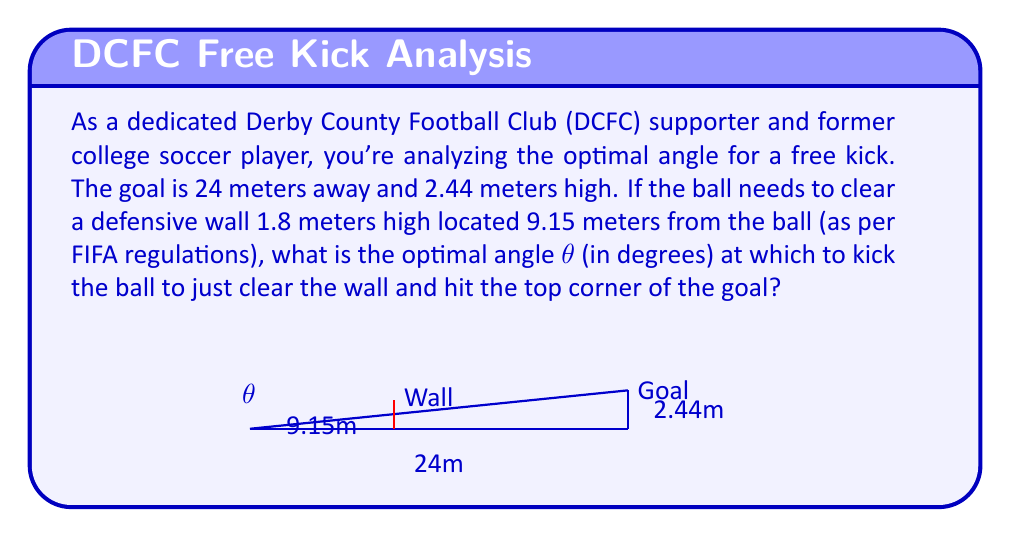Provide a solution to this math problem. Let's approach this step-by-step using trigonometry:

1) First, we need to find the angle that just clears the wall. We can use the tangent function for this:

   $$\tan(\theta_1) = \frac{1.8}{9.15}$$

2) Solving for θ₁:
   
   $$\theta_1 = \arctan(\frac{1.8}{9.15}) \approx 11.12°$$

3) Now, we need to find the angle to the top corner of the goal. Again, using tangent:

   $$\tan(\theta_2) = \frac{2.44}{24}$$

4) Solving for θ₂:
   
   $$\theta_2 = \arctan(\frac{2.44}{24}) \approx 5.81°$$

5) The optimal angle θ should be between these two angles, slightly higher than θ₂ to ensure the ball clears the wall but not as high as θ₁ to avoid overshooting the goal.

6) We can take the average of these two angles as a good approximation:

   $$\theta = \frac{\theta_1 + \theta_2}{2} = \frac{11.12° + 5.81°}{2} \approx 8.47°$$

This angle should allow the ball to just clear the wall and hit the top corner of the goal.
Answer: The optimal angle θ for the free kick is approximately 8.47°. 